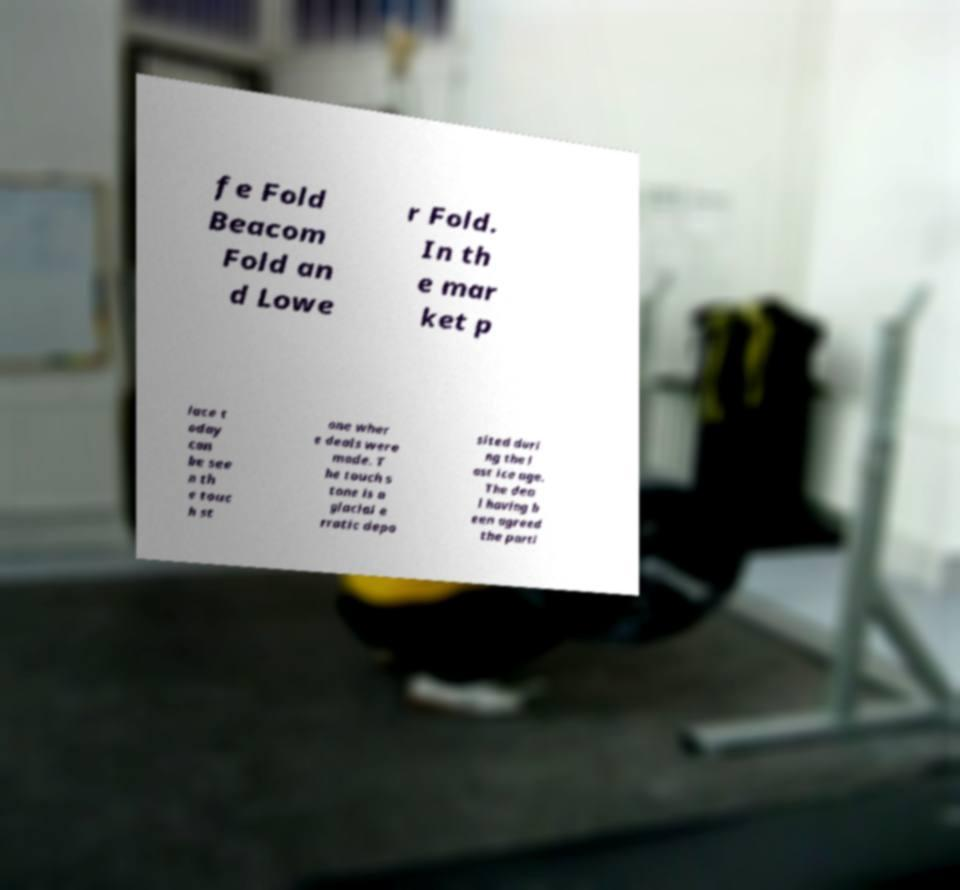Please read and relay the text visible in this image. What does it say? fe Fold Beacom Fold an d Lowe r Fold. In th e mar ket p lace t oday can be see n th e touc h st one wher e deals were made. T he touch s tone is a glacial e rratic depo sited duri ng the l ast ice age. The dea l having b een agreed the parti 